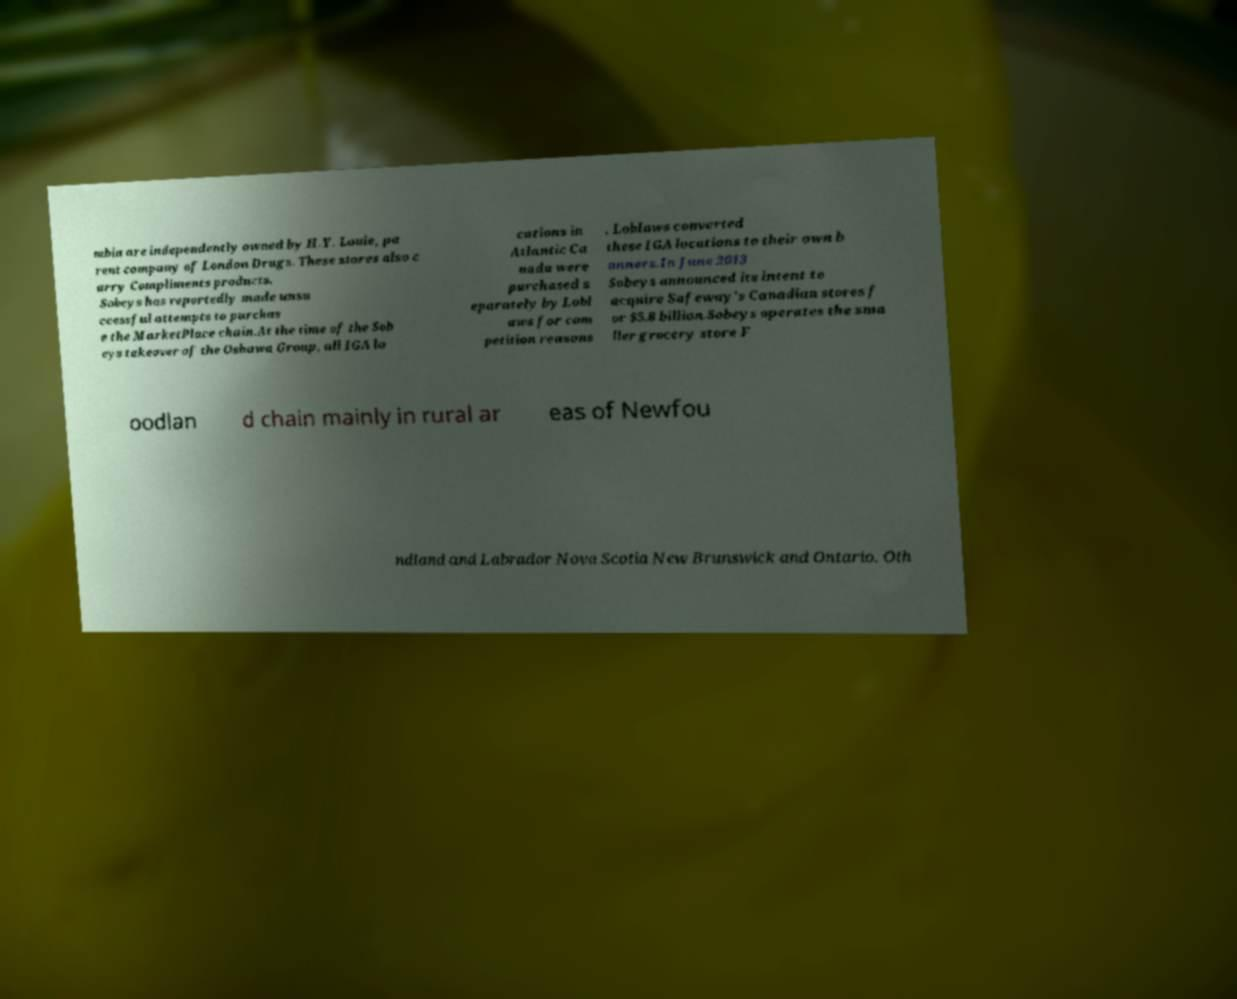There's text embedded in this image that I need extracted. Can you transcribe it verbatim? mbia are independently owned by H.Y. Louie, pa rent company of London Drugs. These stores also c arry Compliments products. Sobeys has reportedly made unsu ccessful attempts to purchas e the MarketPlace chain.At the time of the Sob eys takeover of the Oshawa Group, all IGA lo cations in Atlantic Ca nada were purchased s eparately by Lobl aws for com petition reasons . Loblaws converted these IGA locations to their own b anners.In June 2013 Sobeys announced its intent to acquire Safeway's Canadian stores f or $5.8 billion.Sobeys operates the sma ller grocery store F oodlan d chain mainly in rural ar eas of Newfou ndland and Labrador Nova Scotia New Brunswick and Ontario. Oth 